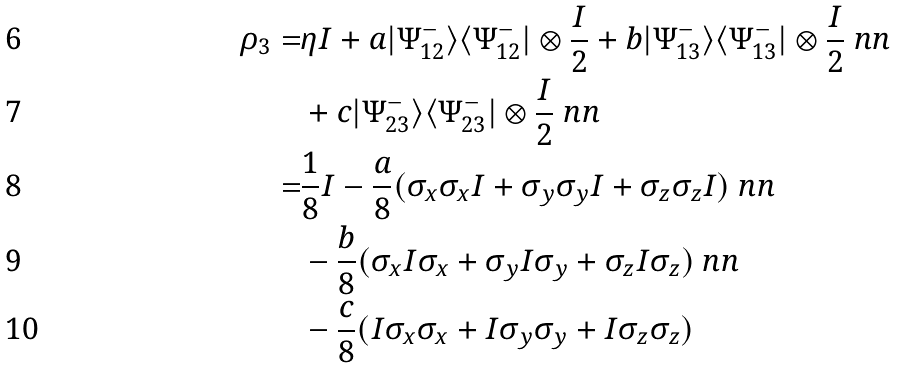Convert formula to latex. <formula><loc_0><loc_0><loc_500><loc_500>\rho _ { 3 } = & \eta I + a | \Psi _ { 1 2 } ^ { - } \rangle \langle \Psi _ { 1 2 } ^ { - } | \otimes \frac { I } { 2 } + b | \Psi _ { 1 3 } ^ { - } \rangle \langle \Psi _ { 1 3 } ^ { - } | \otimes \frac { I } { 2 } \ n n \\ & + c | \Psi _ { 2 3 } ^ { - } \rangle \langle \Psi _ { 2 3 } ^ { - } | \otimes \frac { I } { 2 } \ n n \\ = & \frac { 1 } { 8 } I - \frac { a } { 8 } ( \sigma _ { x } \sigma _ { x } I + \sigma _ { y } \sigma _ { y } I + \sigma _ { z } \sigma _ { z } I ) \ n n \\ & - \frac { b } { 8 } ( \sigma _ { x } I \sigma _ { x } + \sigma _ { y } I \sigma _ { y } + \sigma _ { z } I \sigma _ { z } ) \ n n \\ & - \frac { c } { 8 } ( I \sigma _ { x } \sigma _ { x } + I \sigma _ { y } \sigma _ { y } + I \sigma _ { z } \sigma _ { z } )</formula> 